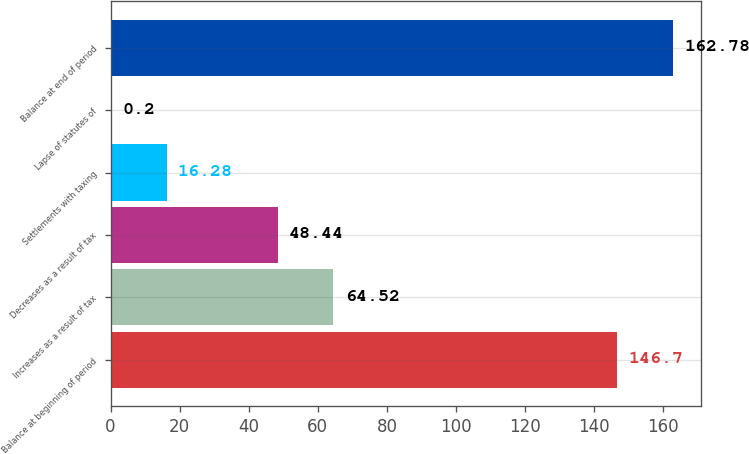Convert chart. <chart><loc_0><loc_0><loc_500><loc_500><bar_chart><fcel>Balance at beginning of period<fcel>Increases as a result of tax<fcel>Decreases as a result of tax<fcel>Settlements with taxing<fcel>Lapse of statutes of<fcel>Balance at end of period<nl><fcel>146.7<fcel>64.52<fcel>48.44<fcel>16.28<fcel>0.2<fcel>162.78<nl></chart> 